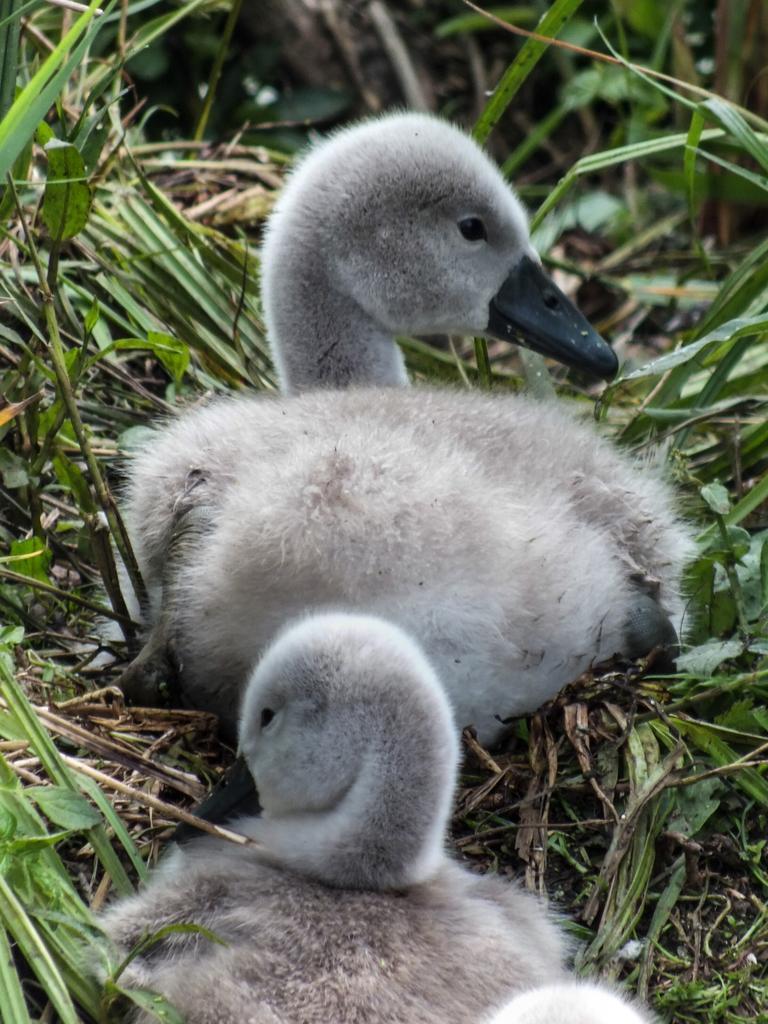Could you give a brief overview of what you see in this image? In this image we can see birds and grass. 